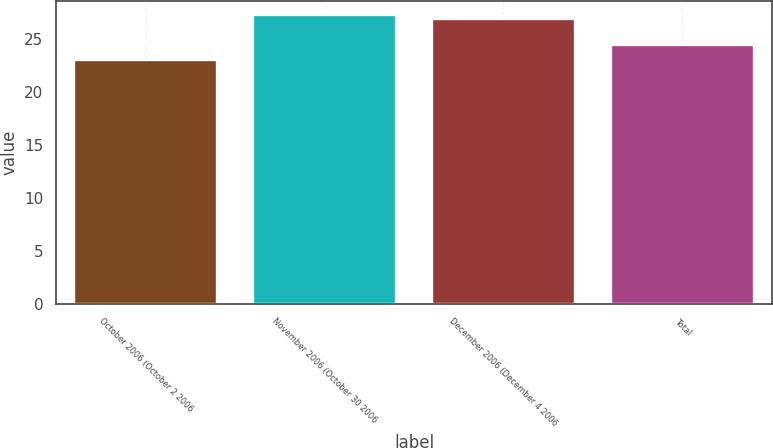Convert chart. <chart><loc_0><loc_0><loc_500><loc_500><bar_chart><fcel>October 2006 (October 2 2006<fcel>November 2006 (October 30 2006<fcel>December 2006 (December 4 2006<fcel>Total<nl><fcel>22.98<fcel>27.21<fcel>26.82<fcel>24.4<nl></chart> 